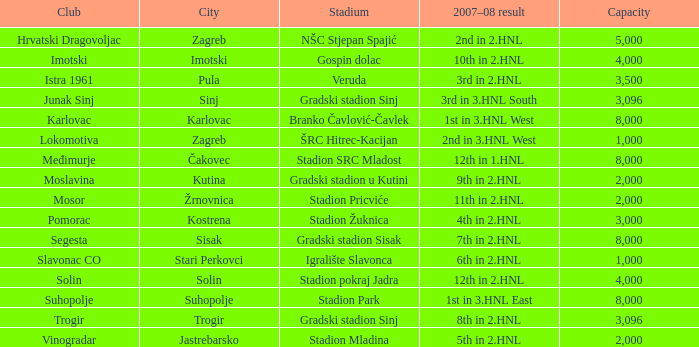What club achieved 3rd place in Junak Sinj. 